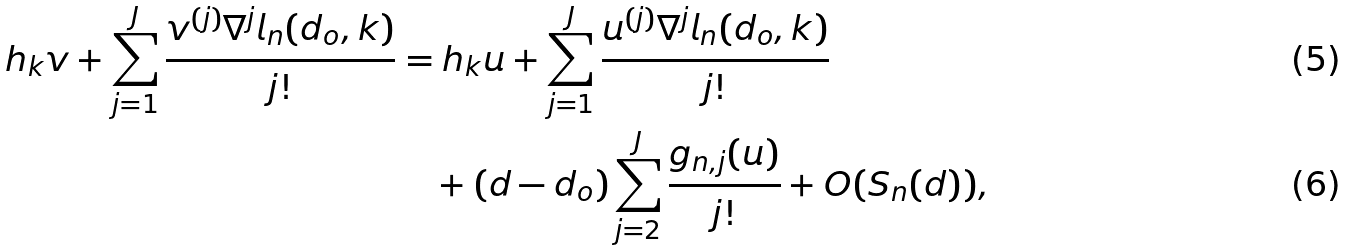Convert formula to latex. <formula><loc_0><loc_0><loc_500><loc_500>h _ { k } v + \sum _ { j = 1 } ^ { J } \frac { v ^ { ( j ) } \nabla ^ { j } l _ { n } ( d _ { o } , k ) } { j ! } & = h _ { k } u + \sum _ { j = 1 } ^ { J } \frac { u ^ { ( j ) } \nabla ^ { j } l _ { n } ( d _ { o } , k ) } { j ! } \\ & \quad + ( d - d _ { o } ) \sum _ { j = 2 } ^ { J } \frac { g _ { n , j } ( u ) } { j ! } + O ( S _ { n } ( d ) ) ,</formula> 